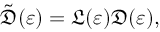Convert formula to latex. <formula><loc_0><loc_0><loc_500><loc_500>\tilde { \mathfrak { D } } ( \varepsilon ) = \mathfrak { L } ( \varepsilon ) \mathfrak { D } ( \varepsilon ) ,</formula> 